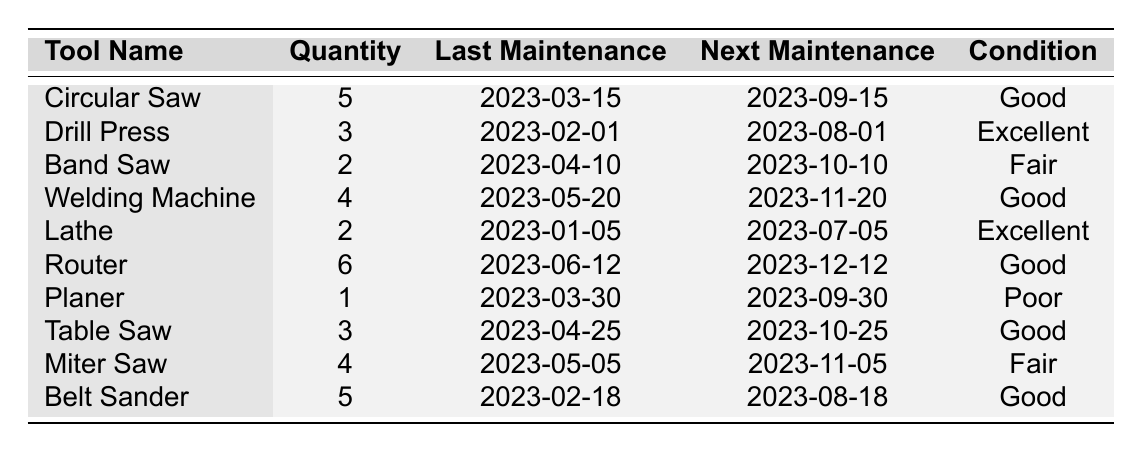What is the condition of the Lathe? The table indicates that the Lathe is listed under "Condition," where its value is shown as "Excellent."
Answer: Excellent How many tools need maintenance before the end of September? By examining the "Next Maintenance" column, the tools with their next maintenance date before the end of September are Circular Saw, Drill Press, Planer, and Table Saw. This totals to 4 tools.
Answer: 4 How many total tools are available in the shop class? To find the total quantity of tools, sum all the quantities listed in the "Quantity" column: 5 (Circular Saw) + 3 (Drill Press) + 2 (Band Saw) + 4 (Welding Machine) + 2 (Lathe) + 6 (Router) + 1 (Planer) + 3 (Table Saw) + 4 (Miter Saw) + 5 (Belt Sander) = 35.
Answer: 35 Is the condition of the Drill Press "Good"? The condition of the Drill Press is listed as "Excellent" in the table, therefore it is not "Good."
Answer: No Which tool has the next maintenance scheduled after the Planer? The Planer is scheduled for maintenance on "2023-09-30." The next tool with a maintenance date after this is the Router, which is scheduled for "2023-12-12."
Answer: Router Are there more Circular Saws than Miter Saws in terms of quantity? Comparing the quantity columns, Circular Saw has 5, while Miter Saw has 4. Since 5 is greater than 4, there are indeed more Circular Saws.
Answer: Yes What is the average quantity of tools in good condition? Identify tools in "Good" condition: Circular Saw (5), Welding Machine (4), Router (6), Table Saw (3), and Belt Sander (5). Sum: 5 + 4 + 6 + 3 + 5 = 23. Count of tools is 5, thus the average is 23/5 = 4.6.
Answer: 4.6 Which tool has the lowest quantity? Looking at the quantity column, the Planer has the lowest quantity with a total of 1.
Answer: Planer How many tools are in poor condition? The only tool listed under "Poor" condition is the Planer, which means there is 1 tool in poor condition.
Answer: 1 